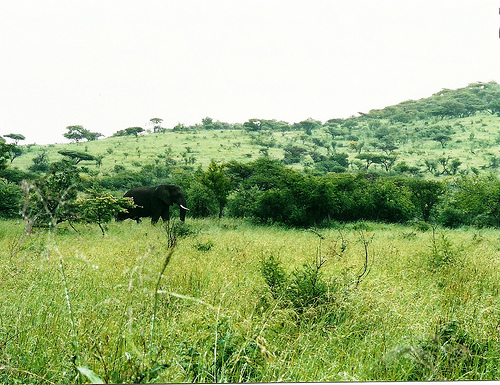<image>
Can you confirm if the elephant is in front of the tree? No. The elephant is not in front of the tree. The spatial positioning shows a different relationship between these objects. 